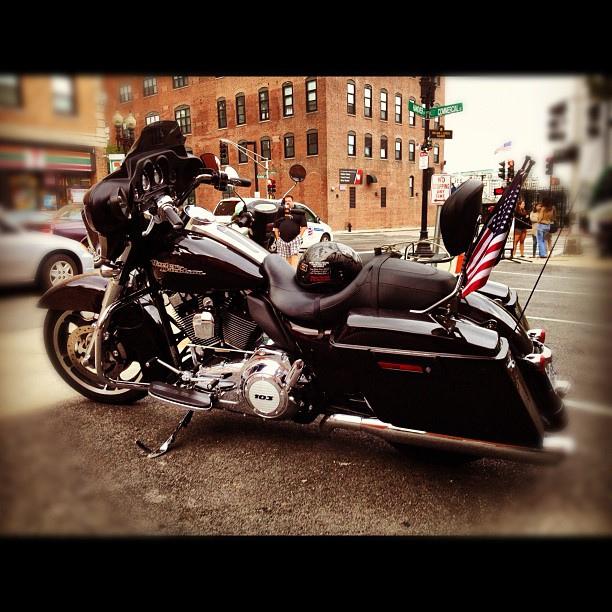What is sitting on the seat of the motorcycle?
Quick response, please. Helmet. Where is an American flag in the picture?
Write a very short answer. Yes. What country's flag is on the bike?
Be succinct. Usa. 